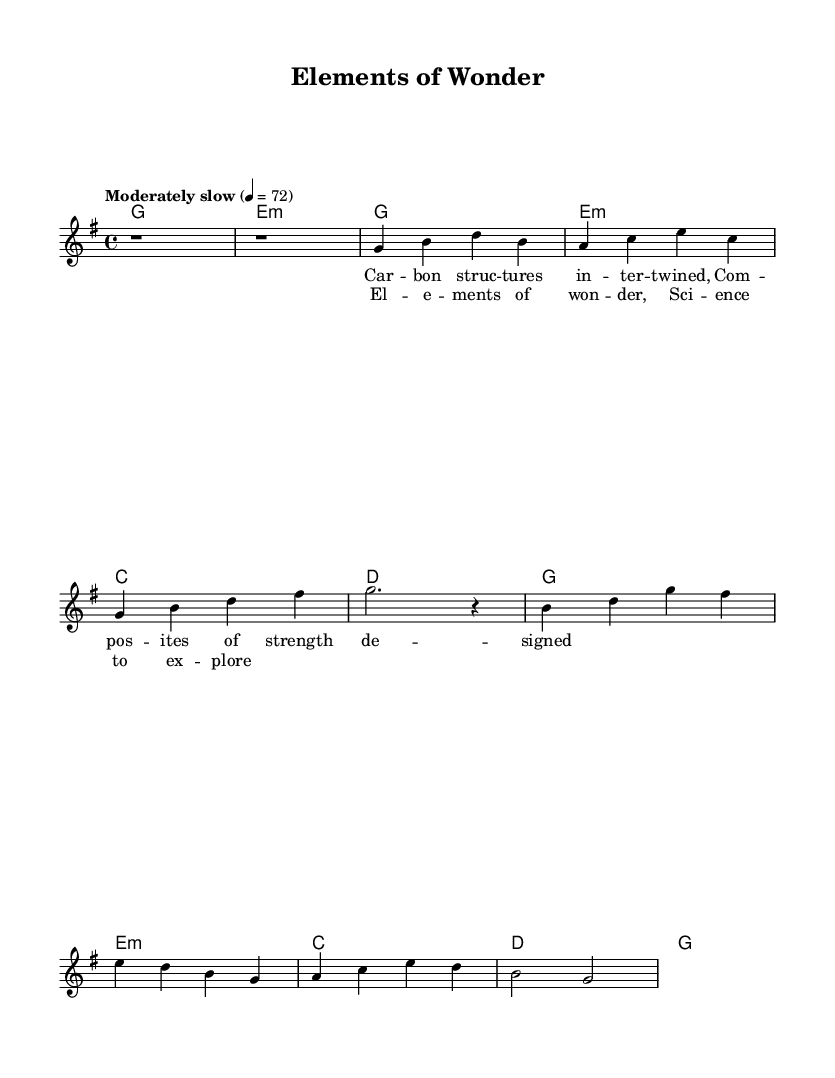What is the tempo marking of the music? The tempo marking is indicated as "Moderately slow" with a metronome marking of 4 = 72. This specifies how fast the music should be played.
Answer: Moderately slow What is the time signature of this piece? The time signature appears at the beginning of the score and is indicated as 4/4, meaning there are four beats in each measure and the quarter note gets one beat.
Answer: 4/4 What key is this music written in? The key signature is G major, which is indicated by the presence of one sharp (F sharp). This key governs the pitches used throughout the piece.
Answer: G major How many measures are in the verse? By counting the segments separated by bar lines within the verse, we find there are four measures represented. This reflects the structure of this section of the music.
Answer: 4 What chords are used in the chorus? The chords indicated in the score for the chorus are G major, E minor, C major, D major. This is derived from the chord changes following the melody line for the chorus section.
Answer: G, E minor, C, D What is the first lyric line of the verse? The first lyric line of the verse is "Car -- bon struc -- tures in -- ter -- twined," which can be read directly beneath the corresponding notes in the vocal part.
Answer: Car -- bon struc -- tures in -- ter -- twined Which section follows the intro? The structure of the piece indicates that after the intro, the first verse follows. The measures are organized sequentially, leading directly into the verse after the introductory bars.
Answer: Verse 1 